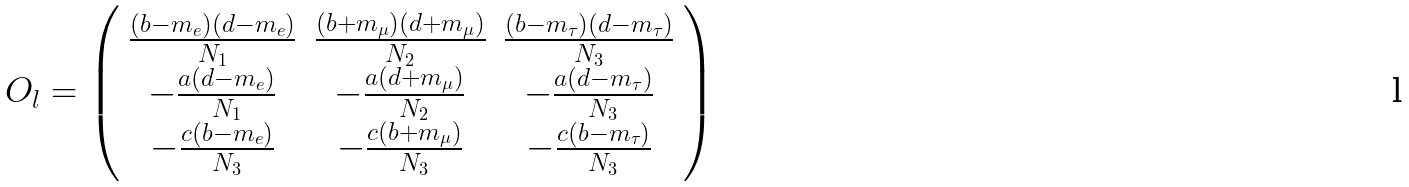Convert formula to latex. <formula><loc_0><loc_0><loc_500><loc_500>O _ { l } = \left ( \begin{array} { c c c } \frac { ( b - m _ { e } ) ( d - m _ { e } ) } { N _ { 1 } } & \frac { ( b + m _ { \mu } ) ( d + m _ { \mu } ) } { N _ { 2 } } & \frac { ( b - m _ { \tau } ) ( d - m _ { \tau } ) } { N _ { 3 } } \\ - \frac { a ( d - m _ { e } ) } { N _ { 1 } } & - \frac { a ( d + m _ { \mu } ) } { N _ { 2 } } & - \frac { a ( d - m _ { \tau } ) } { N _ { 3 } } \\ - \frac { c ( b - m _ { e } ) } { N _ { 3 } } & - \frac { c ( b + m _ { \mu } ) } { N _ { 3 } } & - \frac { c ( b - m _ { \tau } ) } { N _ { 3 } } \end{array} \right )</formula> 